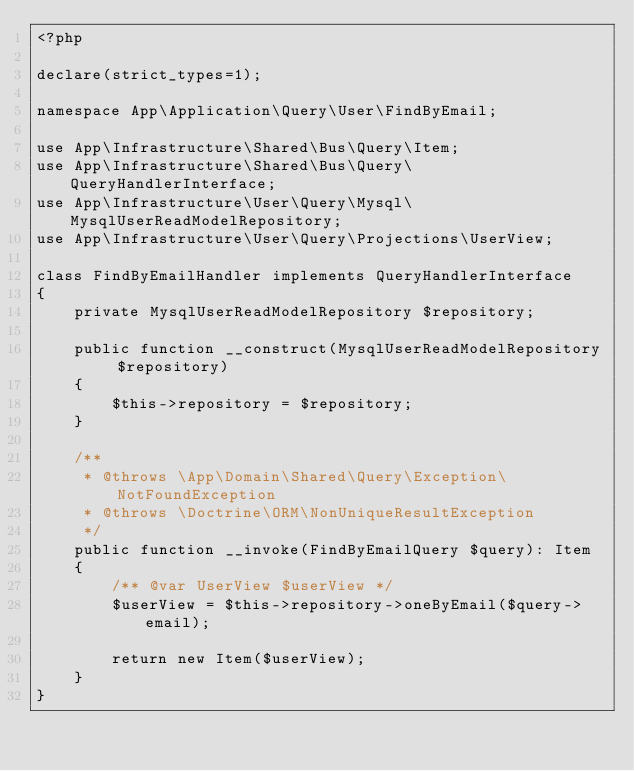<code> <loc_0><loc_0><loc_500><loc_500><_PHP_><?php

declare(strict_types=1);

namespace App\Application\Query\User\FindByEmail;

use App\Infrastructure\Shared\Bus\Query\Item;
use App\Infrastructure\Shared\Bus\Query\QueryHandlerInterface;
use App\Infrastructure\User\Query\Mysql\MysqlUserReadModelRepository;
use App\Infrastructure\User\Query\Projections\UserView;

class FindByEmailHandler implements QueryHandlerInterface
{
    private MysqlUserReadModelRepository $repository;

    public function __construct(MysqlUserReadModelRepository $repository)
    {
        $this->repository = $repository;
    }

    /**
     * @throws \App\Domain\Shared\Query\Exception\NotFoundException
     * @throws \Doctrine\ORM\NonUniqueResultException
     */
    public function __invoke(FindByEmailQuery $query): Item
    {
        /** @var UserView $userView */
        $userView = $this->repository->oneByEmail($query->email);

        return new Item($userView);
    }
}
</code> 